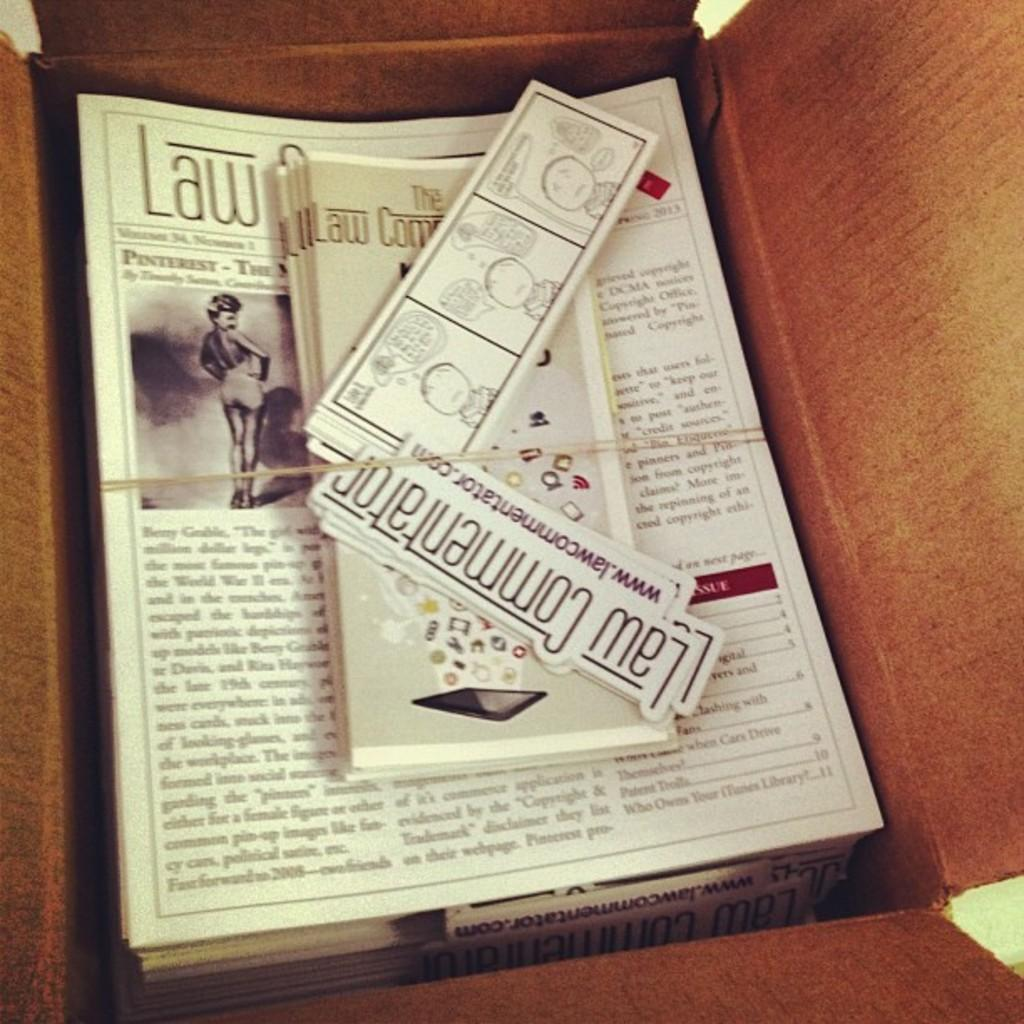<image>
Summarize the visual content of the image. A stack of Law Commentator pamphlets and stickers. 